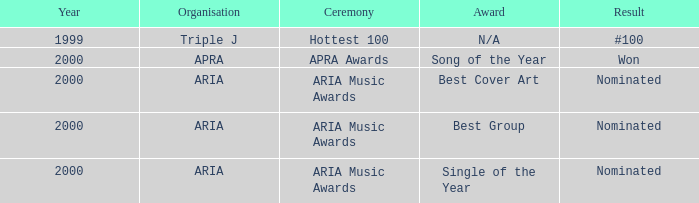Which award was nominated for in 2000? Best Cover Art, Best Group, Single of the Year. 